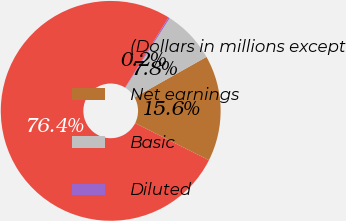<chart> <loc_0><loc_0><loc_500><loc_500><pie_chart><fcel>(Dollars in millions except<fcel>Net earnings<fcel>Basic<fcel>Diluted<nl><fcel>76.42%<fcel>15.58%<fcel>7.81%<fcel>0.19%<nl></chart> 